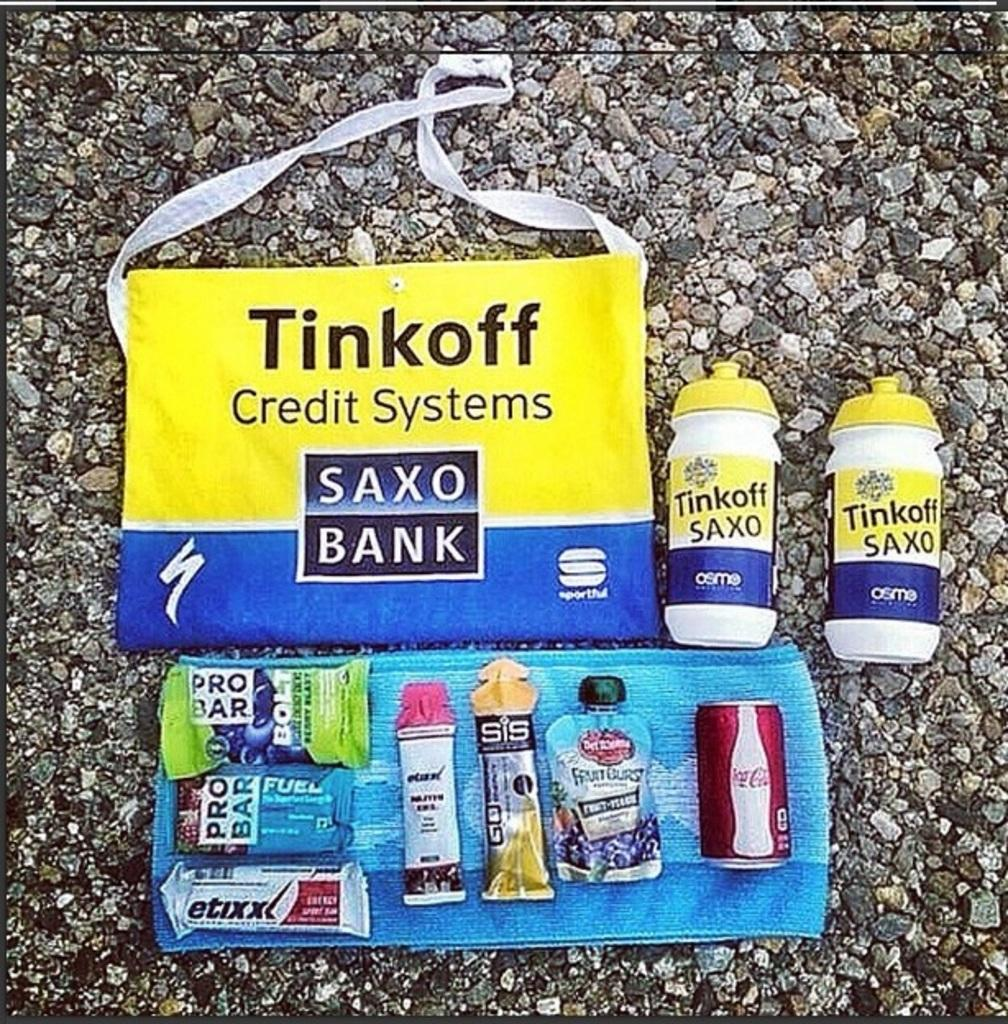Provide a one-sentence caption for the provided image. Handbag with samples from a bank credit system. 